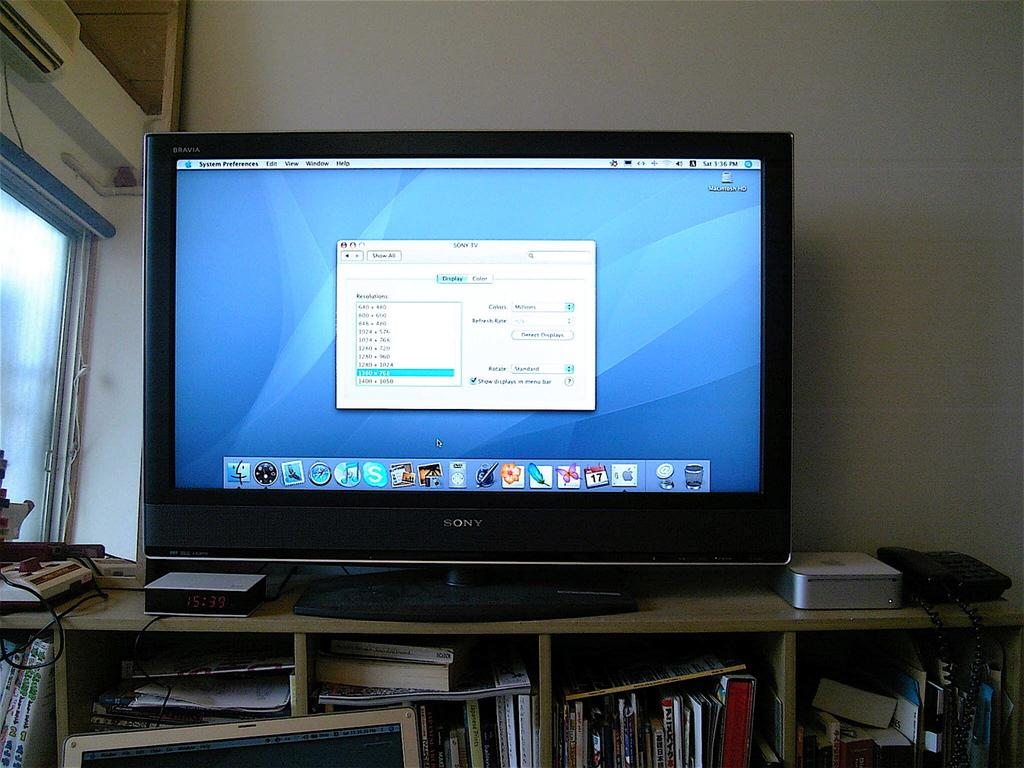Provide a one-sentence caption for the provided image. A large monitor is on a cabinet and it is showing screen resolution settings. 